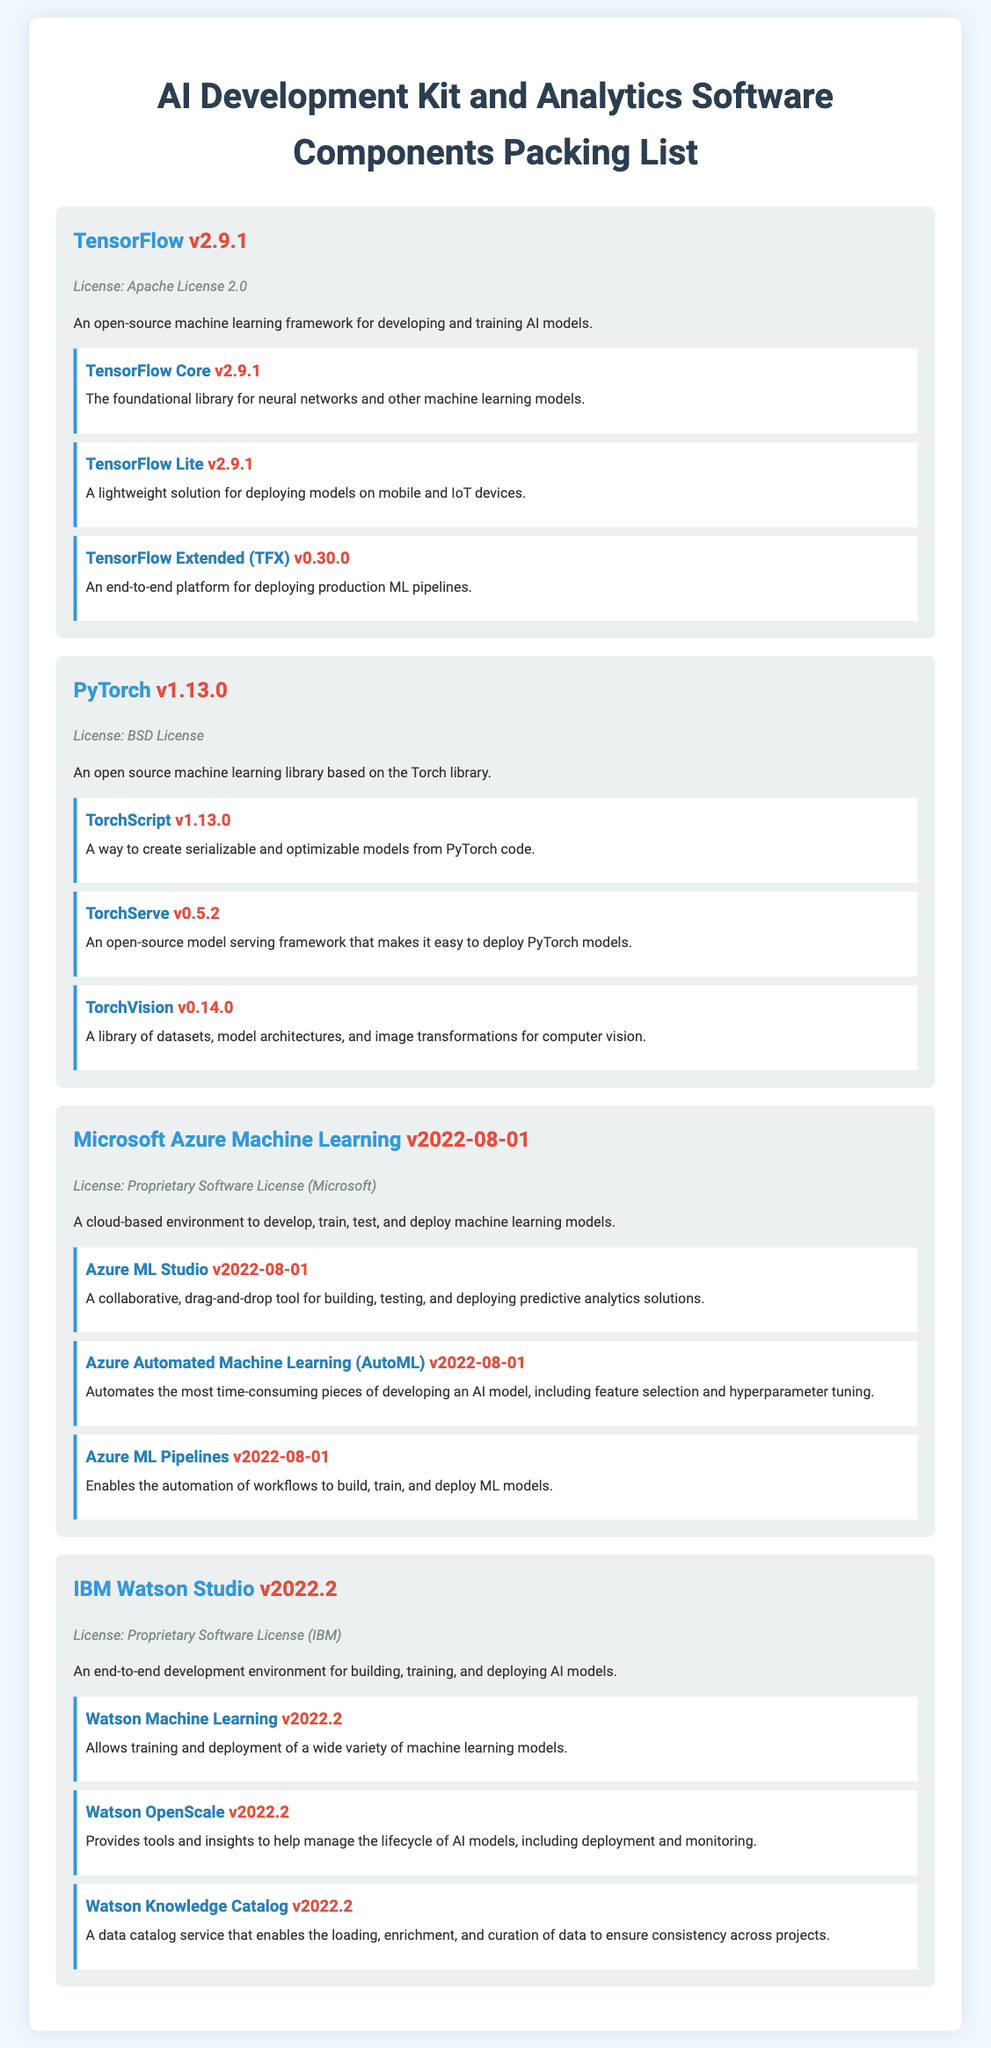What is the version of TensorFlow? The version of TensorFlow mentioned in the document is v2.9.1.
Answer: v2.9.1 What license is associated with PyTorch? The license associated with PyTorch is the BSD License.
Answer: BSD License What is TensorFlow Extended used for? TensorFlow Extended (TFX) is used for deploying production ML pipelines.
Answer: Deploying production ML pipelines How many components are listed under Microsoft Azure Machine Learning? There are three components listed under Microsoft Azure Machine Learning.
Answer: Three Which AI Development Kit has a proprietary software license? Both Microsoft Azure Machine Learning and IBM Watson Studio have proprietary software licenses.
Answer: Microsoft Azure Machine Learning, IBM Watson Studio What is the description of Watson Knowledge Catalog? Watson Knowledge Catalog is a data catalog service that enables the loading, enrichment, and curation of data to ensure consistency across projects.
Answer: Data catalog service What is the version of Azure ML Pipelines? The version of Azure ML Pipelines is v2022-08-01.
Answer: v2022-08-01 Which component of PyTorch provides image transformations for computer vision? TorchVision provides datasets, model architectures, and image transformations for computer vision.
Answer: TorchVision What is the version of Watson Machine Learning? The version of Watson Machine Learning is v2022.2.
Answer: v2022.2 